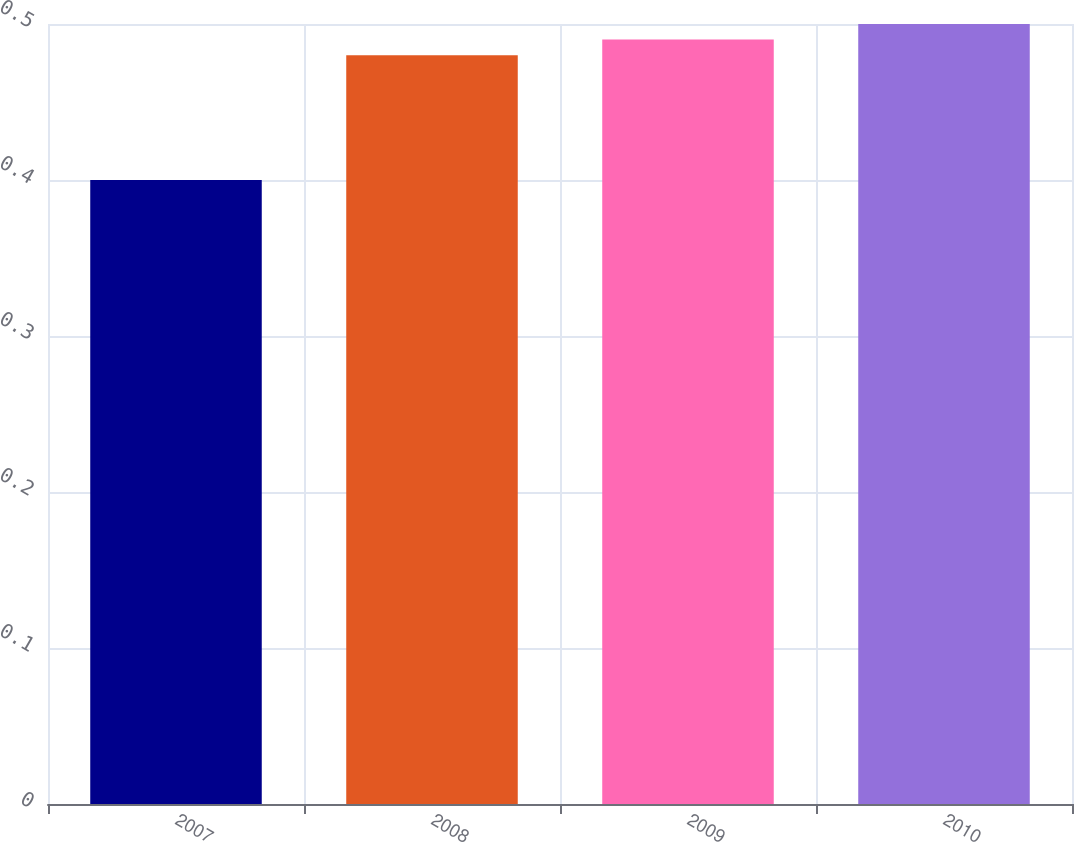Convert chart. <chart><loc_0><loc_0><loc_500><loc_500><bar_chart><fcel>2007<fcel>2008<fcel>2009<fcel>2010<nl><fcel>0.4<fcel>0.48<fcel>0.49<fcel>0.5<nl></chart> 